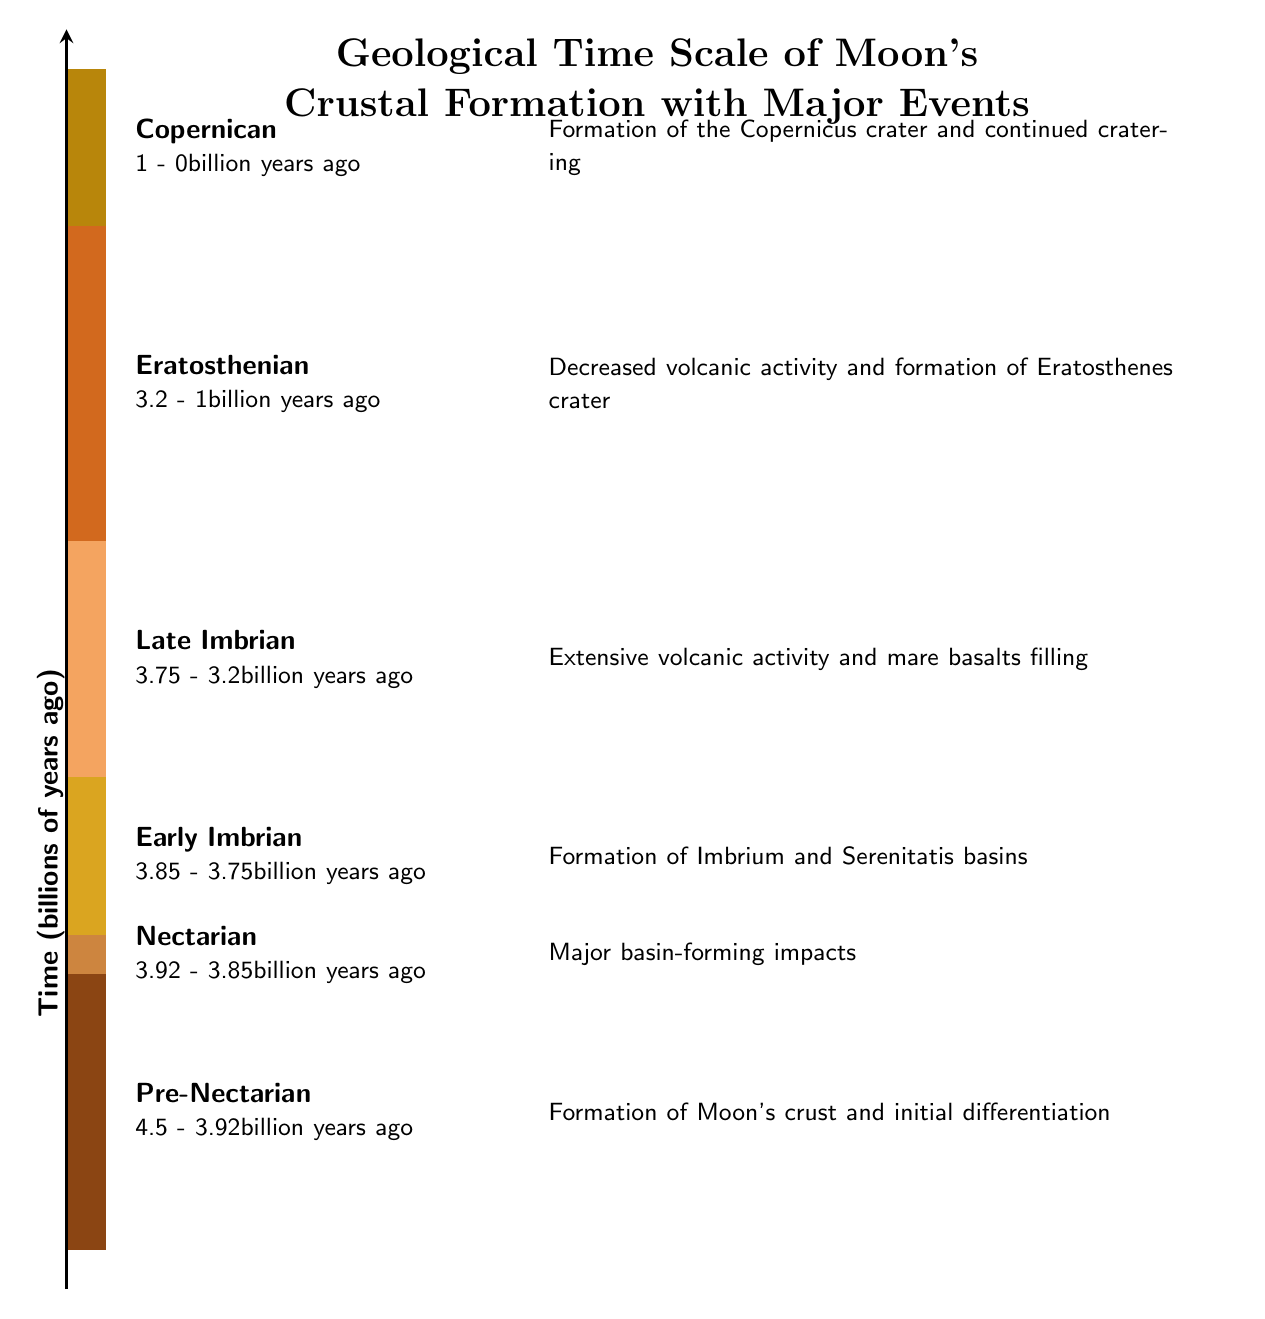What is the oldest epoch on the geological time scale? The oldest epoch listed in the diagram is the Pre-Nectarian, which is at the bottom of the timeline.
Answer: Pre-Nectarian How many major events are described in the diagram? The diagram shows a total of six major events, one for each epoch represented.
Answer: 6 What billion years ago did the major basin-forming impacts occur? The major basin-forming impacts occurred around 3.92 to 3.85 billion years ago, as indicated in the Nectarian epoch.
Answer: 3.92 - 3.85 Which epoch has the longest duration? The Late Imbrian epoch has a duration from 3.75 to 3.2 billion years ago, which is a span of 0.55 billion years.
Answer: Late Imbrian What is a key event during the Early Imbrian epoch? During the Early Imbrian epoch, the formation of Imbrium and Serenitatis basins occurred. This information is presented alongside the epoch in the diagram.
Answer: Formation of Imbrium and Serenitatis basins How does volcanic activity change from the Late Imbrian to the Eratosthenian epoch? The diagram indicates a decrease in volcanic activity as we move from the Late Imbrian to the Eratosthenian epoch, signifying a significant geological change.
Answer: Decreased volcanic activity What is the temporal range of the Copernican epoch? The Copernican epoch spans from 1 billion years ago to the present, as noted in its description in the diagram.
Answer: 1 - 0 Which epoch followed the Nectarian epoch? The Early Imbrian epoch follows the Nectarian epoch as illustrated in the timeline sequence.
Answer: Early Imbrian What event coincides with the formation of the Copernicus crater? The event associated with the formation of the Copernicus crater is mentioned as part of the Copernican epoch, where continued cratering also occurs.
Answer: Formation of the Copernicus crater and continued cratering 